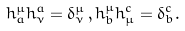<formula> <loc_0><loc_0><loc_500><loc_500>h _ { a } ^ { \mu } h _ { \nu } ^ { a } = \delta _ { \nu } ^ { \mu } \, , h _ { b } ^ { \mu } h _ { \mu } ^ { c } = \delta _ { b } ^ { c } .</formula> 